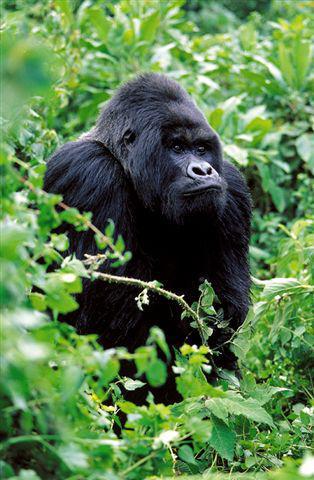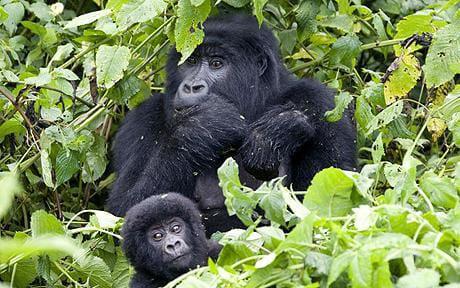The first image is the image on the left, the second image is the image on the right. Analyze the images presented: Is the assertion "A group of four or more gorillas is assembled in the forest." valid? Answer yes or no. No. The first image is the image on the left, the second image is the image on the right. For the images shown, is this caption "One image contains at least eight apes." true? Answer yes or no. No. 